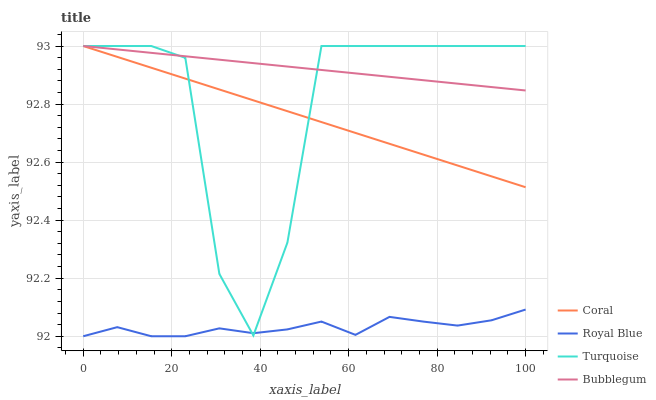Does Royal Blue have the minimum area under the curve?
Answer yes or no. Yes. Does Bubblegum have the maximum area under the curve?
Answer yes or no. Yes. Does Coral have the minimum area under the curve?
Answer yes or no. No. Does Coral have the maximum area under the curve?
Answer yes or no. No. Is Coral the smoothest?
Answer yes or no. Yes. Is Turquoise the roughest?
Answer yes or no. Yes. Is Turquoise the smoothest?
Answer yes or no. No. Is Coral the roughest?
Answer yes or no. No. Does Royal Blue have the lowest value?
Answer yes or no. Yes. Does Coral have the lowest value?
Answer yes or no. No. Does Bubblegum have the highest value?
Answer yes or no. Yes. Is Royal Blue less than Coral?
Answer yes or no. Yes. Is Coral greater than Royal Blue?
Answer yes or no. Yes. Does Coral intersect Turquoise?
Answer yes or no. Yes. Is Coral less than Turquoise?
Answer yes or no. No. Is Coral greater than Turquoise?
Answer yes or no. No. Does Royal Blue intersect Coral?
Answer yes or no. No. 